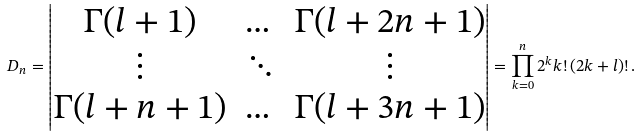<formula> <loc_0><loc_0><loc_500><loc_500>D _ { n } = \left | \begin{matrix} \Gamma ( l + 1 ) & \dots & \Gamma ( l + 2 n + 1 ) \\ \vdots & \ddots & \vdots \\ \Gamma ( l + n + 1 ) & \dots & \Gamma ( l + 3 n + 1 ) \end{matrix} \right | = \prod _ { k = 0 } ^ { n } 2 ^ { k } k ! \, ( 2 k + l ) ! \, .</formula> 